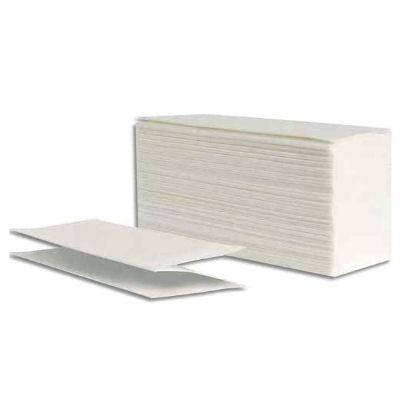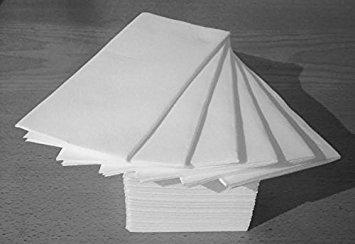The first image is the image on the left, the second image is the image on the right. Considering the images on both sides, is "The right image contains one wrapped pack of folded paper towels, and the left image shows a single folded towel that is not aligned with a neat stack." valid? Answer yes or no. No. The first image is the image on the left, the second image is the image on the right. For the images shown, is this caption "Some paper towels are wrapped in paper." true? Answer yes or no. No. 